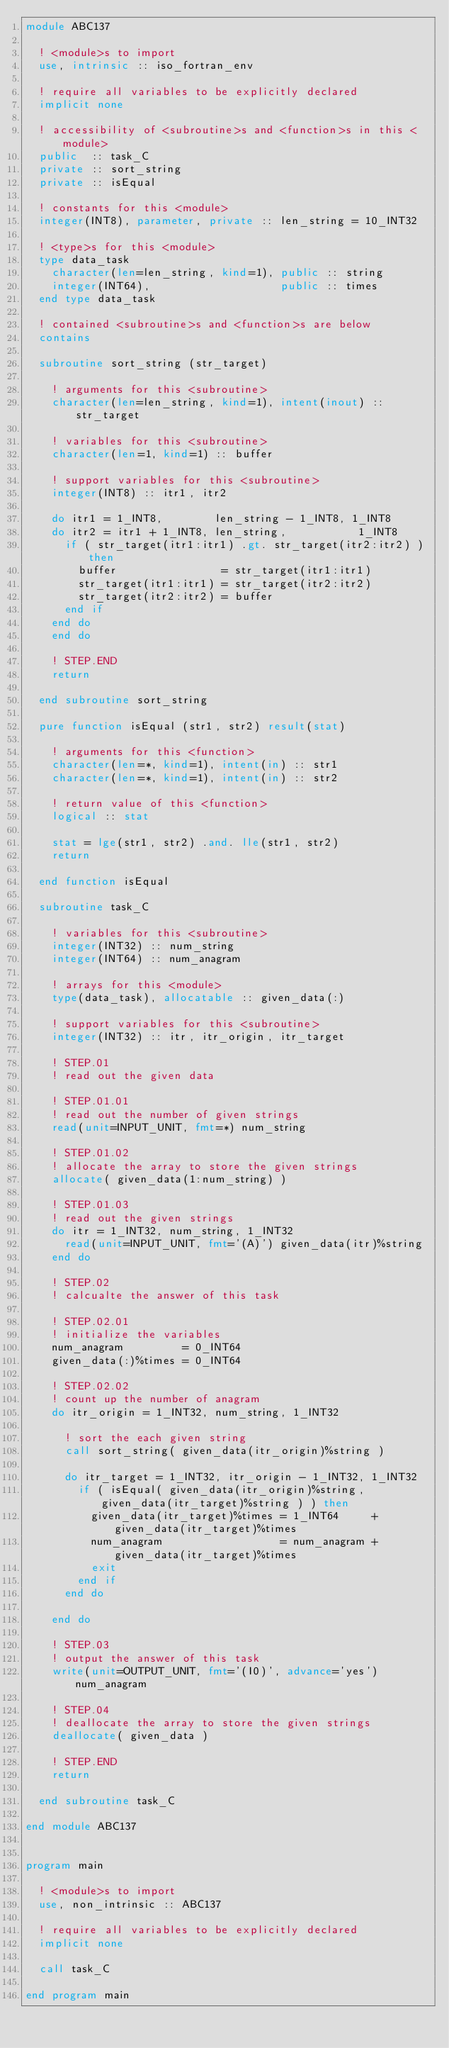Convert code to text. <code><loc_0><loc_0><loc_500><loc_500><_FORTRAN_>module ABC137

  ! <module>s to import
  use, intrinsic :: iso_fortran_env

  ! require all variables to be explicitly declared
  implicit none

  ! accessibility of <subroutine>s and <function>s in this <module>
  public  :: task_C
  private :: sort_string
  private :: isEqual

  ! constants for this <module>
  integer(INT8), parameter, private :: len_string = 10_INT32

  ! <type>s for this <module>
  type data_task
    character(len=len_string, kind=1), public :: string
    integer(INT64),                    public :: times
  end type data_task

  ! contained <subroutine>s and <function>s are below
  contains

  subroutine sort_string (str_target)

    ! arguments for this <subroutine>
    character(len=len_string, kind=1), intent(inout) :: str_target

    ! variables for this <subroutine>
    character(len=1, kind=1) :: buffer

    ! support variables for this <subroutine>
    integer(INT8) :: itr1, itr2

    do itr1 = 1_INT8,        len_string - 1_INT8, 1_INT8
    do itr2 = itr1 + 1_INT8, len_string,           1_INT8
      if ( str_target(itr1:itr1) .gt. str_target(itr2:itr2) ) then
        buffer                = str_target(itr1:itr1)
        str_target(itr1:itr1) = str_target(itr2:itr2)
        str_target(itr2:itr2) = buffer
      end if
    end do
    end do

    ! STEP.END
    return

  end subroutine sort_string

  pure function isEqual (str1, str2) result(stat)

    ! arguments for this <function>
    character(len=*, kind=1), intent(in) :: str1
    character(len=*, kind=1), intent(in) :: str2

    ! return value of this <function>
    logical :: stat
    
    stat = lge(str1, str2) .and. lle(str1, str2)
    return

  end function isEqual

  subroutine task_C

    ! variables for this <subroutine>
    integer(INT32) :: num_string
    integer(INT64) :: num_anagram

    ! arrays for this <module>
    type(data_task), allocatable :: given_data(:)

    ! support variables for this <subroutine>
    integer(INT32) :: itr, itr_origin, itr_target

    ! STEP.01
    ! read out the given data

    ! STEP.01.01
    ! read out the number of given strings
    read(unit=INPUT_UNIT, fmt=*) num_string

    ! STEP.01.02
    ! allocate the array to store the given strings
    allocate( given_data(1:num_string) )

    ! STEP.01.03
    ! read out the given strings
    do itr = 1_INT32, num_string, 1_INT32
      read(unit=INPUT_UNIT, fmt='(A)') given_data(itr)%string
    end do

    ! STEP.02
    ! calcualte the answer of this task

    ! STEP.02.01
    ! initialize the variables
    num_anagram         = 0_INT64
    given_data(:)%times = 0_INT64

    ! STEP.02.02
    ! count up the number of anagram
    do itr_origin = 1_INT32, num_string, 1_INT32
      
      ! sort the each given string
      call sort_string( given_data(itr_origin)%string )

      do itr_target = 1_INT32, itr_origin - 1_INT32, 1_INT32
        if ( isEqual( given_data(itr_origin)%string, given_data(itr_target)%string ) ) then
          given_data(itr_target)%times = 1_INT64     + given_data(itr_target)%times
          num_anagram                  = num_anagram + given_data(itr_target)%times
          exit
        end if
      end do

    end do

    ! STEP.03
    ! output the answer of this task
    write(unit=OUTPUT_UNIT, fmt='(I0)', advance='yes') num_anagram

    ! STEP.04
    ! deallocate the array to store the given strings
    deallocate( given_data )

    ! STEP.END
    return

  end subroutine task_C

end module ABC137


program main

  ! <module>s to import
  use, non_intrinsic :: ABC137

  ! require all variables to be explicitly declared
  implicit none

  call task_C

end program main</code> 